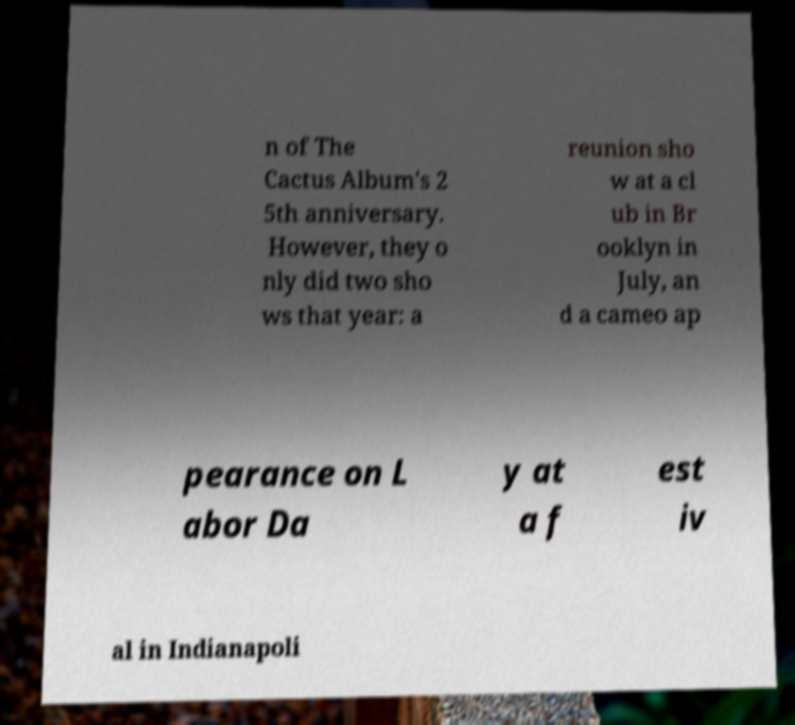What messages or text are displayed in this image? I need them in a readable, typed format. n of The Cactus Album's 2 5th anniversary. However, they o nly did two sho ws that year: a reunion sho w at a cl ub in Br ooklyn in July, an d a cameo ap pearance on L abor Da y at a f est iv al in Indianapoli 